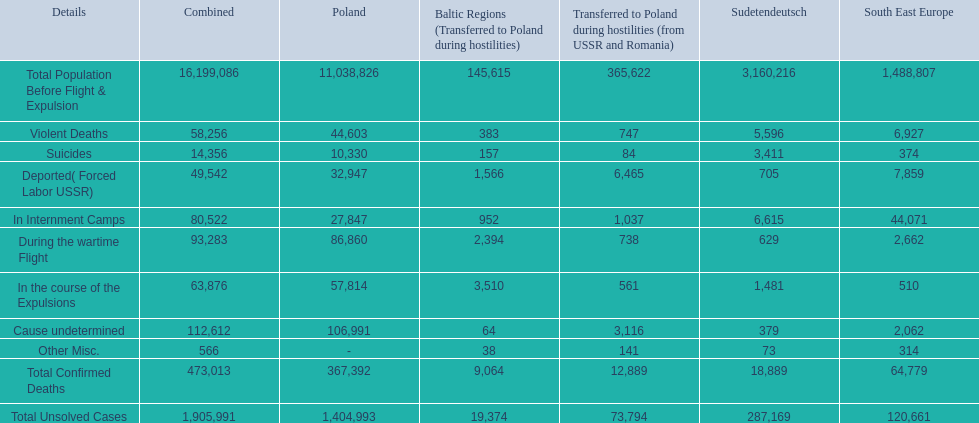How many deaths did the baltic states have in each category? 145,615, 383, 157, 1,566, 952, 2,394, 3,510, 64, 38, 9,064, 19,374. How many cause undetermined deaths did baltic states have? 64. How many other miscellaneous deaths did baltic states have? 38. Which is higher in deaths, cause undetermined or other miscellaneous? Cause undetermined. 